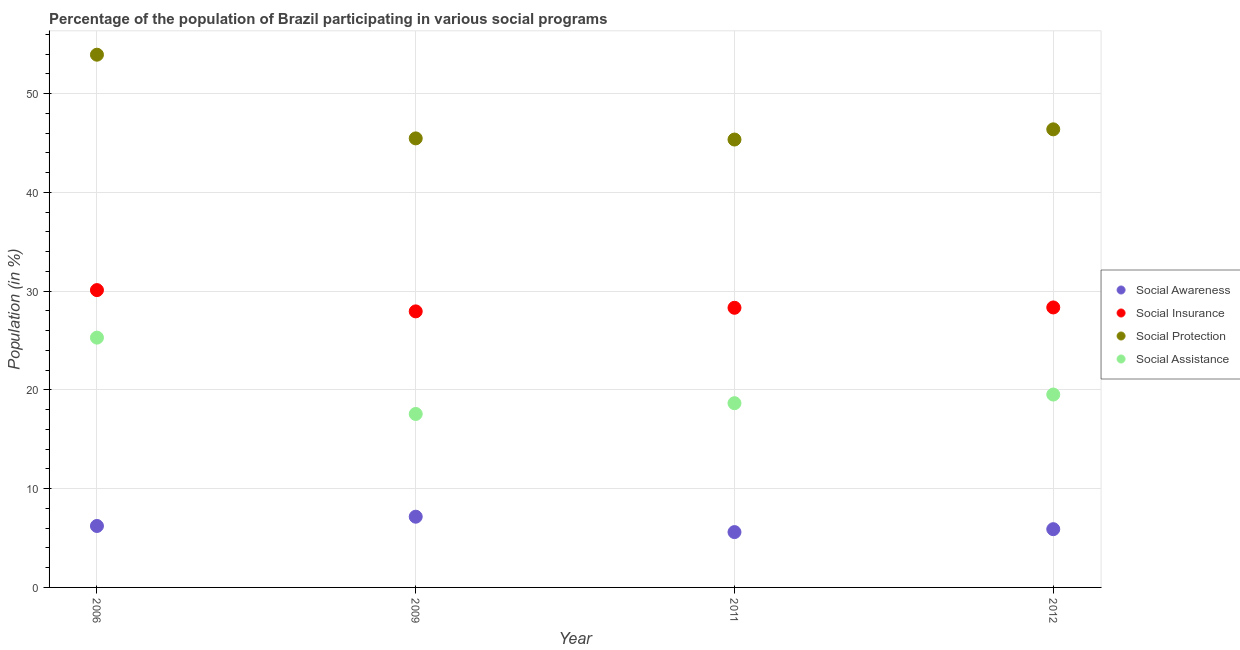Is the number of dotlines equal to the number of legend labels?
Keep it short and to the point. Yes. What is the participation of population in social awareness programs in 2006?
Offer a very short reply. 6.22. Across all years, what is the maximum participation of population in social protection programs?
Your response must be concise. 53.93. Across all years, what is the minimum participation of population in social assistance programs?
Your answer should be compact. 17.56. In which year was the participation of population in social awareness programs maximum?
Provide a short and direct response. 2009. In which year was the participation of population in social protection programs minimum?
Your answer should be very brief. 2011. What is the total participation of population in social awareness programs in the graph?
Provide a succinct answer. 24.88. What is the difference between the participation of population in social insurance programs in 2006 and that in 2011?
Your answer should be compact. 1.79. What is the difference between the participation of population in social assistance programs in 2011 and the participation of population in social awareness programs in 2012?
Offer a terse response. 12.75. What is the average participation of population in social awareness programs per year?
Make the answer very short. 6.22. In the year 2012, what is the difference between the participation of population in social awareness programs and participation of population in social assistance programs?
Offer a very short reply. -13.63. In how many years, is the participation of population in social awareness programs greater than 32 %?
Your answer should be very brief. 0. What is the ratio of the participation of population in social protection programs in 2006 to that in 2012?
Offer a terse response. 1.16. What is the difference between the highest and the second highest participation of population in social insurance programs?
Keep it short and to the point. 1.76. What is the difference between the highest and the lowest participation of population in social protection programs?
Offer a terse response. 8.59. Is it the case that in every year, the sum of the participation of population in social awareness programs and participation of population in social insurance programs is greater than the participation of population in social protection programs?
Offer a terse response. No. Does the participation of population in social insurance programs monotonically increase over the years?
Make the answer very short. No. Is the participation of population in social protection programs strictly less than the participation of population in social awareness programs over the years?
Make the answer very short. No. How many years are there in the graph?
Offer a very short reply. 4. What is the difference between two consecutive major ticks on the Y-axis?
Offer a terse response. 10. Are the values on the major ticks of Y-axis written in scientific E-notation?
Your answer should be very brief. No. Does the graph contain grids?
Ensure brevity in your answer.  Yes. Where does the legend appear in the graph?
Offer a very short reply. Center right. How many legend labels are there?
Ensure brevity in your answer.  4. How are the legend labels stacked?
Give a very brief answer. Vertical. What is the title of the graph?
Keep it short and to the point. Percentage of the population of Brazil participating in various social programs . Does "Third 20% of population" appear as one of the legend labels in the graph?
Provide a short and direct response. No. What is the Population (in %) of Social Awareness in 2006?
Make the answer very short. 6.22. What is the Population (in %) in Social Insurance in 2006?
Give a very brief answer. 30.1. What is the Population (in %) of Social Protection in 2006?
Your answer should be very brief. 53.93. What is the Population (in %) of Social Assistance in 2006?
Your answer should be compact. 25.29. What is the Population (in %) of Social Awareness in 2009?
Your response must be concise. 7.16. What is the Population (in %) in Social Insurance in 2009?
Offer a terse response. 27.95. What is the Population (in %) in Social Protection in 2009?
Your answer should be compact. 45.46. What is the Population (in %) of Social Assistance in 2009?
Give a very brief answer. 17.56. What is the Population (in %) in Social Awareness in 2011?
Your answer should be very brief. 5.6. What is the Population (in %) of Social Insurance in 2011?
Your response must be concise. 28.31. What is the Population (in %) of Social Protection in 2011?
Offer a very short reply. 45.34. What is the Population (in %) of Social Assistance in 2011?
Your answer should be very brief. 18.65. What is the Population (in %) in Social Awareness in 2012?
Your answer should be very brief. 5.9. What is the Population (in %) in Social Insurance in 2012?
Your answer should be compact. 28.34. What is the Population (in %) in Social Protection in 2012?
Offer a terse response. 46.38. What is the Population (in %) of Social Assistance in 2012?
Provide a short and direct response. 19.53. Across all years, what is the maximum Population (in %) in Social Awareness?
Your response must be concise. 7.16. Across all years, what is the maximum Population (in %) in Social Insurance?
Offer a terse response. 30.1. Across all years, what is the maximum Population (in %) in Social Protection?
Keep it short and to the point. 53.93. Across all years, what is the maximum Population (in %) in Social Assistance?
Your response must be concise. 25.29. Across all years, what is the minimum Population (in %) of Social Awareness?
Your answer should be compact. 5.6. Across all years, what is the minimum Population (in %) of Social Insurance?
Give a very brief answer. 27.95. Across all years, what is the minimum Population (in %) in Social Protection?
Make the answer very short. 45.34. Across all years, what is the minimum Population (in %) in Social Assistance?
Your answer should be very brief. 17.56. What is the total Population (in %) of Social Awareness in the graph?
Your response must be concise. 24.88. What is the total Population (in %) of Social Insurance in the graph?
Your answer should be compact. 114.7. What is the total Population (in %) in Social Protection in the graph?
Provide a short and direct response. 191.11. What is the total Population (in %) in Social Assistance in the graph?
Make the answer very short. 81.03. What is the difference between the Population (in %) of Social Awareness in 2006 and that in 2009?
Your answer should be compact. -0.94. What is the difference between the Population (in %) in Social Insurance in 2006 and that in 2009?
Give a very brief answer. 2.15. What is the difference between the Population (in %) in Social Protection in 2006 and that in 2009?
Make the answer very short. 8.47. What is the difference between the Population (in %) of Social Assistance in 2006 and that in 2009?
Ensure brevity in your answer.  7.73. What is the difference between the Population (in %) in Social Awareness in 2006 and that in 2011?
Provide a succinct answer. 0.62. What is the difference between the Population (in %) of Social Insurance in 2006 and that in 2011?
Your answer should be compact. 1.79. What is the difference between the Population (in %) of Social Protection in 2006 and that in 2011?
Keep it short and to the point. 8.59. What is the difference between the Population (in %) in Social Assistance in 2006 and that in 2011?
Your answer should be very brief. 6.64. What is the difference between the Population (in %) of Social Awareness in 2006 and that in 2012?
Provide a succinct answer. 0.32. What is the difference between the Population (in %) of Social Insurance in 2006 and that in 2012?
Your answer should be compact. 1.76. What is the difference between the Population (in %) of Social Protection in 2006 and that in 2012?
Your answer should be compact. 7.56. What is the difference between the Population (in %) in Social Assistance in 2006 and that in 2012?
Offer a very short reply. 5.76. What is the difference between the Population (in %) of Social Awareness in 2009 and that in 2011?
Provide a succinct answer. 1.56. What is the difference between the Population (in %) of Social Insurance in 2009 and that in 2011?
Offer a terse response. -0.36. What is the difference between the Population (in %) of Social Protection in 2009 and that in 2011?
Make the answer very short. 0.12. What is the difference between the Population (in %) of Social Assistance in 2009 and that in 2011?
Offer a terse response. -1.09. What is the difference between the Population (in %) of Social Awareness in 2009 and that in 2012?
Your response must be concise. 1.26. What is the difference between the Population (in %) of Social Insurance in 2009 and that in 2012?
Ensure brevity in your answer.  -0.4. What is the difference between the Population (in %) of Social Protection in 2009 and that in 2012?
Make the answer very short. -0.92. What is the difference between the Population (in %) of Social Assistance in 2009 and that in 2012?
Keep it short and to the point. -1.97. What is the difference between the Population (in %) in Social Awareness in 2011 and that in 2012?
Keep it short and to the point. -0.3. What is the difference between the Population (in %) in Social Insurance in 2011 and that in 2012?
Offer a very short reply. -0.03. What is the difference between the Population (in %) in Social Protection in 2011 and that in 2012?
Your response must be concise. -1.03. What is the difference between the Population (in %) of Social Assistance in 2011 and that in 2012?
Your response must be concise. -0.88. What is the difference between the Population (in %) of Social Awareness in 2006 and the Population (in %) of Social Insurance in 2009?
Your answer should be very brief. -21.73. What is the difference between the Population (in %) in Social Awareness in 2006 and the Population (in %) in Social Protection in 2009?
Your answer should be very brief. -39.24. What is the difference between the Population (in %) of Social Awareness in 2006 and the Population (in %) of Social Assistance in 2009?
Offer a terse response. -11.34. What is the difference between the Population (in %) in Social Insurance in 2006 and the Population (in %) in Social Protection in 2009?
Offer a very short reply. -15.36. What is the difference between the Population (in %) in Social Insurance in 2006 and the Population (in %) in Social Assistance in 2009?
Your response must be concise. 12.54. What is the difference between the Population (in %) in Social Protection in 2006 and the Population (in %) in Social Assistance in 2009?
Your answer should be very brief. 36.37. What is the difference between the Population (in %) in Social Awareness in 2006 and the Population (in %) in Social Insurance in 2011?
Provide a short and direct response. -22.09. What is the difference between the Population (in %) in Social Awareness in 2006 and the Population (in %) in Social Protection in 2011?
Ensure brevity in your answer.  -39.12. What is the difference between the Population (in %) in Social Awareness in 2006 and the Population (in %) in Social Assistance in 2011?
Give a very brief answer. -12.43. What is the difference between the Population (in %) in Social Insurance in 2006 and the Population (in %) in Social Protection in 2011?
Your answer should be very brief. -15.24. What is the difference between the Population (in %) of Social Insurance in 2006 and the Population (in %) of Social Assistance in 2011?
Offer a terse response. 11.45. What is the difference between the Population (in %) in Social Protection in 2006 and the Population (in %) in Social Assistance in 2011?
Provide a short and direct response. 35.28. What is the difference between the Population (in %) in Social Awareness in 2006 and the Population (in %) in Social Insurance in 2012?
Make the answer very short. -22.12. What is the difference between the Population (in %) in Social Awareness in 2006 and the Population (in %) in Social Protection in 2012?
Offer a very short reply. -40.16. What is the difference between the Population (in %) of Social Awareness in 2006 and the Population (in %) of Social Assistance in 2012?
Offer a very short reply. -13.31. What is the difference between the Population (in %) in Social Insurance in 2006 and the Population (in %) in Social Protection in 2012?
Your response must be concise. -16.28. What is the difference between the Population (in %) of Social Insurance in 2006 and the Population (in %) of Social Assistance in 2012?
Your answer should be very brief. 10.57. What is the difference between the Population (in %) of Social Protection in 2006 and the Population (in %) of Social Assistance in 2012?
Provide a short and direct response. 34.4. What is the difference between the Population (in %) in Social Awareness in 2009 and the Population (in %) in Social Insurance in 2011?
Provide a short and direct response. -21.15. What is the difference between the Population (in %) in Social Awareness in 2009 and the Population (in %) in Social Protection in 2011?
Keep it short and to the point. -38.18. What is the difference between the Population (in %) of Social Awareness in 2009 and the Population (in %) of Social Assistance in 2011?
Provide a short and direct response. -11.49. What is the difference between the Population (in %) in Social Insurance in 2009 and the Population (in %) in Social Protection in 2011?
Offer a very short reply. -17.4. What is the difference between the Population (in %) of Social Insurance in 2009 and the Population (in %) of Social Assistance in 2011?
Give a very brief answer. 9.29. What is the difference between the Population (in %) of Social Protection in 2009 and the Population (in %) of Social Assistance in 2011?
Give a very brief answer. 26.81. What is the difference between the Population (in %) of Social Awareness in 2009 and the Population (in %) of Social Insurance in 2012?
Your answer should be compact. -21.18. What is the difference between the Population (in %) of Social Awareness in 2009 and the Population (in %) of Social Protection in 2012?
Keep it short and to the point. -39.22. What is the difference between the Population (in %) of Social Awareness in 2009 and the Population (in %) of Social Assistance in 2012?
Keep it short and to the point. -12.37. What is the difference between the Population (in %) of Social Insurance in 2009 and the Population (in %) of Social Protection in 2012?
Give a very brief answer. -18.43. What is the difference between the Population (in %) of Social Insurance in 2009 and the Population (in %) of Social Assistance in 2012?
Give a very brief answer. 8.42. What is the difference between the Population (in %) of Social Protection in 2009 and the Population (in %) of Social Assistance in 2012?
Offer a terse response. 25.93. What is the difference between the Population (in %) in Social Awareness in 2011 and the Population (in %) in Social Insurance in 2012?
Offer a terse response. -22.74. What is the difference between the Population (in %) of Social Awareness in 2011 and the Population (in %) of Social Protection in 2012?
Keep it short and to the point. -40.77. What is the difference between the Population (in %) of Social Awareness in 2011 and the Population (in %) of Social Assistance in 2012?
Your response must be concise. -13.93. What is the difference between the Population (in %) of Social Insurance in 2011 and the Population (in %) of Social Protection in 2012?
Your answer should be compact. -18.07. What is the difference between the Population (in %) of Social Insurance in 2011 and the Population (in %) of Social Assistance in 2012?
Make the answer very short. 8.78. What is the difference between the Population (in %) of Social Protection in 2011 and the Population (in %) of Social Assistance in 2012?
Offer a terse response. 25.82. What is the average Population (in %) in Social Awareness per year?
Ensure brevity in your answer.  6.22. What is the average Population (in %) of Social Insurance per year?
Offer a very short reply. 28.68. What is the average Population (in %) in Social Protection per year?
Provide a succinct answer. 47.78. What is the average Population (in %) of Social Assistance per year?
Provide a succinct answer. 20.26. In the year 2006, what is the difference between the Population (in %) of Social Awareness and Population (in %) of Social Insurance?
Ensure brevity in your answer.  -23.88. In the year 2006, what is the difference between the Population (in %) of Social Awareness and Population (in %) of Social Protection?
Your answer should be very brief. -47.71. In the year 2006, what is the difference between the Population (in %) of Social Awareness and Population (in %) of Social Assistance?
Ensure brevity in your answer.  -19.07. In the year 2006, what is the difference between the Population (in %) of Social Insurance and Population (in %) of Social Protection?
Make the answer very short. -23.83. In the year 2006, what is the difference between the Population (in %) of Social Insurance and Population (in %) of Social Assistance?
Provide a succinct answer. 4.81. In the year 2006, what is the difference between the Population (in %) in Social Protection and Population (in %) in Social Assistance?
Your answer should be compact. 28.64. In the year 2009, what is the difference between the Population (in %) of Social Awareness and Population (in %) of Social Insurance?
Make the answer very short. -20.79. In the year 2009, what is the difference between the Population (in %) of Social Awareness and Population (in %) of Social Protection?
Offer a terse response. -38.3. In the year 2009, what is the difference between the Population (in %) in Social Awareness and Population (in %) in Social Assistance?
Your answer should be very brief. -10.4. In the year 2009, what is the difference between the Population (in %) in Social Insurance and Population (in %) in Social Protection?
Provide a succinct answer. -17.51. In the year 2009, what is the difference between the Population (in %) of Social Insurance and Population (in %) of Social Assistance?
Your response must be concise. 10.39. In the year 2009, what is the difference between the Population (in %) in Social Protection and Population (in %) in Social Assistance?
Ensure brevity in your answer.  27.9. In the year 2011, what is the difference between the Population (in %) of Social Awareness and Population (in %) of Social Insurance?
Make the answer very short. -22.71. In the year 2011, what is the difference between the Population (in %) in Social Awareness and Population (in %) in Social Protection?
Give a very brief answer. -39.74. In the year 2011, what is the difference between the Population (in %) in Social Awareness and Population (in %) in Social Assistance?
Keep it short and to the point. -13.05. In the year 2011, what is the difference between the Population (in %) in Social Insurance and Population (in %) in Social Protection?
Offer a very short reply. -17.03. In the year 2011, what is the difference between the Population (in %) in Social Insurance and Population (in %) in Social Assistance?
Your response must be concise. 9.66. In the year 2011, what is the difference between the Population (in %) of Social Protection and Population (in %) of Social Assistance?
Your answer should be very brief. 26.69. In the year 2012, what is the difference between the Population (in %) in Social Awareness and Population (in %) in Social Insurance?
Offer a terse response. -22.45. In the year 2012, what is the difference between the Population (in %) in Social Awareness and Population (in %) in Social Protection?
Provide a short and direct response. -40.48. In the year 2012, what is the difference between the Population (in %) in Social Awareness and Population (in %) in Social Assistance?
Offer a very short reply. -13.63. In the year 2012, what is the difference between the Population (in %) in Social Insurance and Population (in %) in Social Protection?
Ensure brevity in your answer.  -18.03. In the year 2012, what is the difference between the Population (in %) in Social Insurance and Population (in %) in Social Assistance?
Ensure brevity in your answer.  8.82. In the year 2012, what is the difference between the Population (in %) in Social Protection and Population (in %) in Social Assistance?
Keep it short and to the point. 26.85. What is the ratio of the Population (in %) in Social Awareness in 2006 to that in 2009?
Make the answer very short. 0.87. What is the ratio of the Population (in %) in Social Insurance in 2006 to that in 2009?
Your answer should be compact. 1.08. What is the ratio of the Population (in %) of Social Protection in 2006 to that in 2009?
Provide a succinct answer. 1.19. What is the ratio of the Population (in %) of Social Assistance in 2006 to that in 2009?
Provide a succinct answer. 1.44. What is the ratio of the Population (in %) of Social Awareness in 2006 to that in 2011?
Keep it short and to the point. 1.11. What is the ratio of the Population (in %) in Social Insurance in 2006 to that in 2011?
Provide a short and direct response. 1.06. What is the ratio of the Population (in %) of Social Protection in 2006 to that in 2011?
Offer a very short reply. 1.19. What is the ratio of the Population (in %) in Social Assistance in 2006 to that in 2011?
Your answer should be very brief. 1.36. What is the ratio of the Population (in %) in Social Awareness in 2006 to that in 2012?
Offer a very short reply. 1.05. What is the ratio of the Population (in %) in Social Insurance in 2006 to that in 2012?
Ensure brevity in your answer.  1.06. What is the ratio of the Population (in %) of Social Protection in 2006 to that in 2012?
Offer a terse response. 1.16. What is the ratio of the Population (in %) of Social Assistance in 2006 to that in 2012?
Give a very brief answer. 1.29. What is the ratio of the Population (in %) of Social Awareness in 2009 to that in 2011?
Ensure brevity in your answer.  1.28. What is the ratio of the Population (in %) of Social Insurance in 2009 to that in 2011?
Your answer should be compact. 0.99. What is the ratio of the Population (in %) in Social Protection in 2009 to that in 2011?
Offer a very short reply. 1. What is the ratio of the Population (in %) of Social Assistance in 2009 to that in 2011?
Keep it short and to the point. 0.94. What is the ratio of the Population (in %) of Social Awareness in 2009 to that in 2012?
Offer a terse response. 1.21. What is the ratio of the Population (in %) in Social Protection in 2009 to that in 2012?
Give a very brief answer. 0.98. What is the ratio of the Population (in %) in Social Assistance in 2009 to that in 2012?
Your answer should be very brief. 0.9. What is the ratio of the Population (in %) in Social Awareness in 2011 to that in 2012?
Provide a succinct answer. 0.95. What is the ratio of the Population (in %) of Social Protection in 2011 to that in 2012?
Your answer should be very brief. 0.98. What is the ratio of the Population (in %) of Social Assistance in 2011 to that in 2012?
Make the answer very short. 0.96. What is the difference between the highest and the second highest Population (in %) in Social Awareness?
Your response must be concise. 0.94. What is the difference between the highest and the second highest Population (in %) of Social Insurance?
Make the answer very short. 1.76. What is the difference between the highest and the second highest Population (in %) of Social Protection?
Your response must be concise. 7.56. What is the difference between the highest and the second highest Population (in %) in Social Assistance?
Your response must be concise. 5.76. What is the difference between the highest and the lowest Population (in %) in Social Awareness?
Offer a very short reply. 1.56. What is the difference between the highest and the lowest Population (in %) in Social Insurance?
Make the answer very short. 2.15. What is the difference between the highest and the lowest Population (in %) in Social Protection?
Your answer should be compact. 8.59. What is the difference between the highest and the lowest Population (in %) of Social Assistance?
Provide a short and direct response. 7.73. 